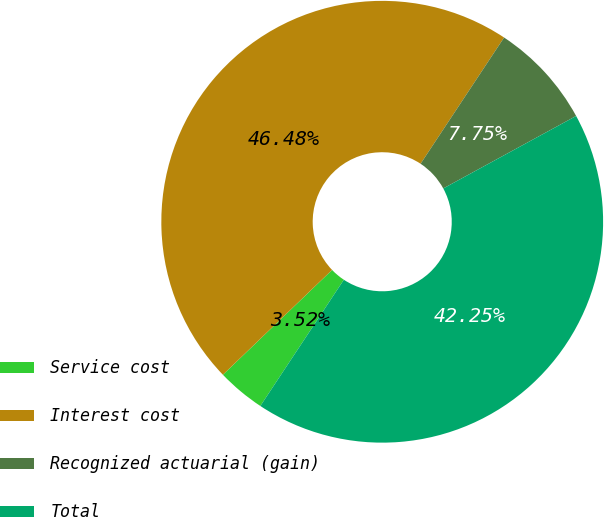<chart> <loc_0><loc_0><loc_500><loc_500><pie_chart><fcel>Service cost<fcel>Interest cost<fcel>Recognized actuarial (gain)<fcel>Total<nl><fcel>3.52%<fcel>46.48%<fcel>7.75%<fcel>42.25%<nl></chart> 